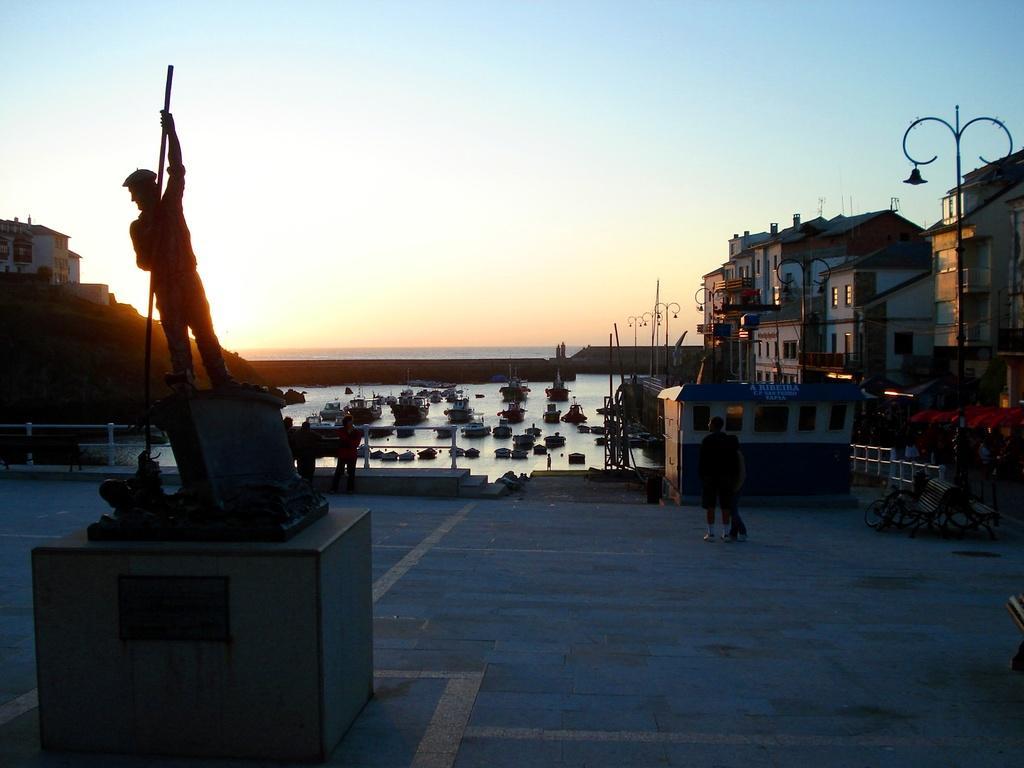Describe this image in one or two sentences. There is a statue of a person holding a stick in the left corner and there are few boats on the water behind it and there are few buildings in the right corner. 